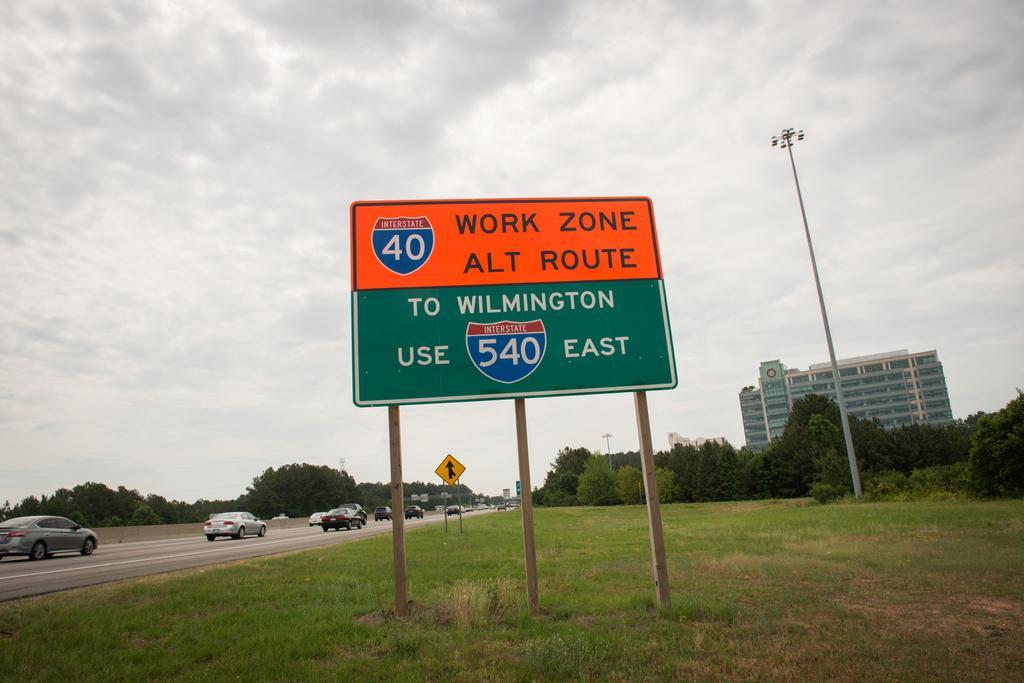Please provide a concise description of this image. In the image there are cars going on the left side, in the front there is board on the grassland, in the back there is building with trees in front of it and above its sky with clouds. 